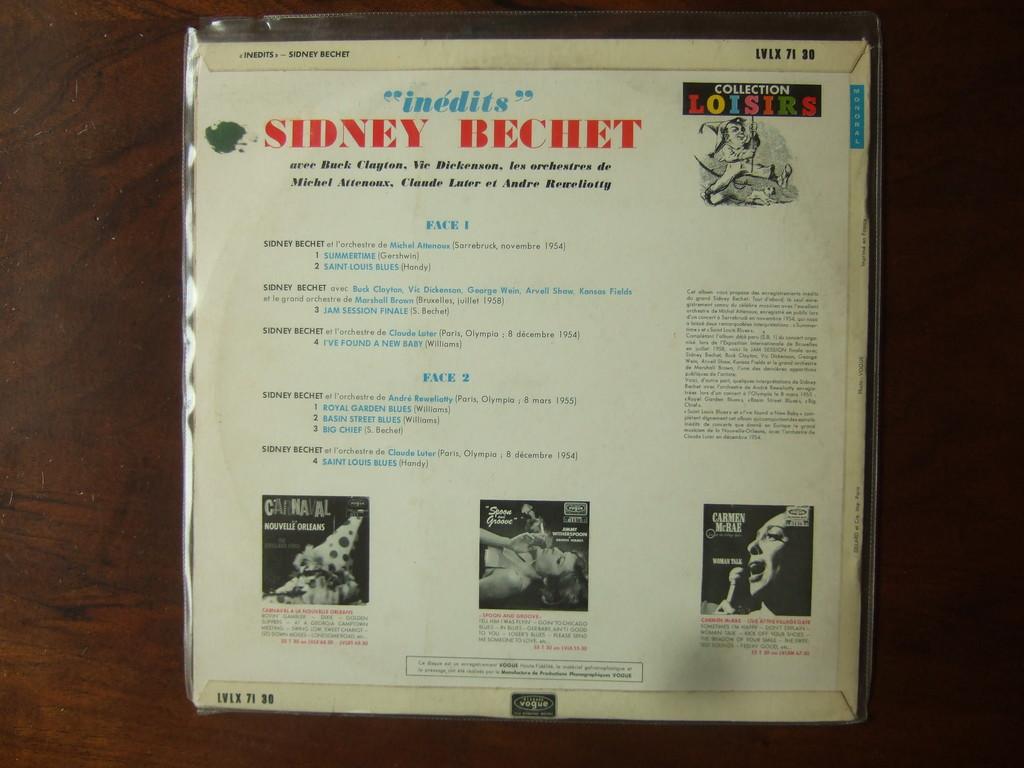What song is on face 2, number 2?
Make the answer very short. Basin street blues. Is this a collection?
Make the answer very short. Yes. 